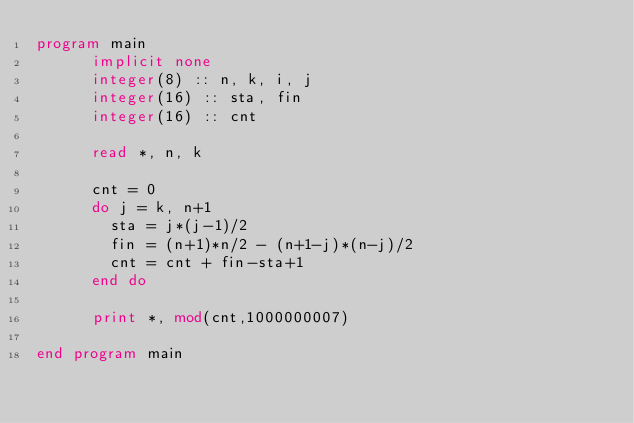Convert code to text. <code><loc_0><loc_0><loc_500><loc_500><_FORTRAN_>program main
      implicit none
      integer(8) :: n, k, i, j
      integer(16) :: sta, fin
      integer(16) :: cnt

      read *, n, k

      cnt = 0
      do j = k, n+1
        sta = j*(j-1)/2
        fin = (n+1)*n/2 - (n+1-j)*(n-j)/2
        cnt = cnt + fin-sta+1
      end do

      print *, mod(cnt,1000000007)

end program main
</code> 